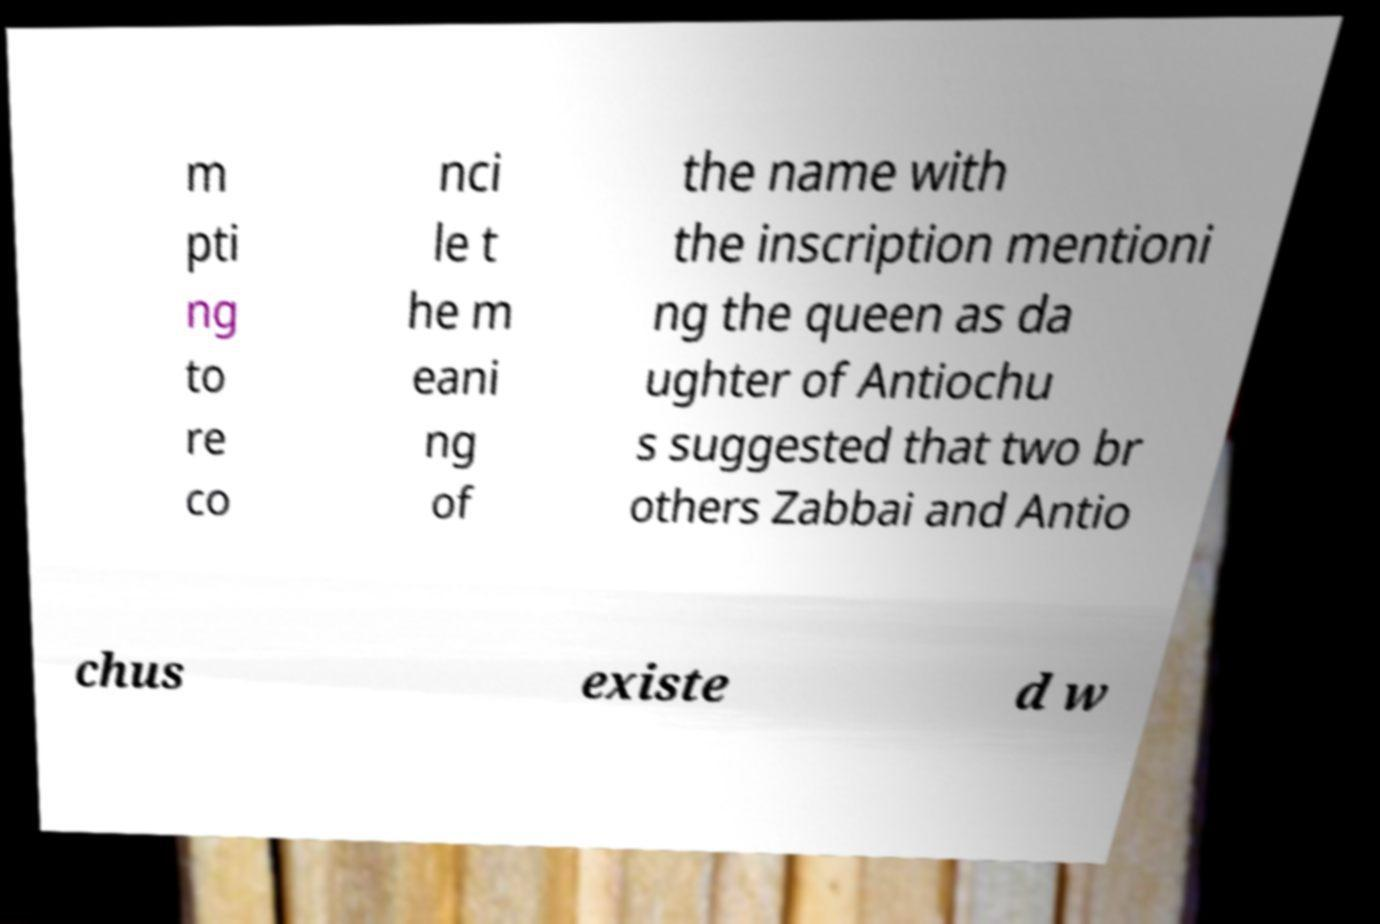Can you read and provide the text displayed in the image?This photo seems to have some interesting text. Can you extract and type it out for me? m pti ng to re co nci le t he m eani ng of the name with the inscription mentioni ng the queen as da ughter of Antiochu s suggested that two br others Zabbai and Antio chus existe d w 